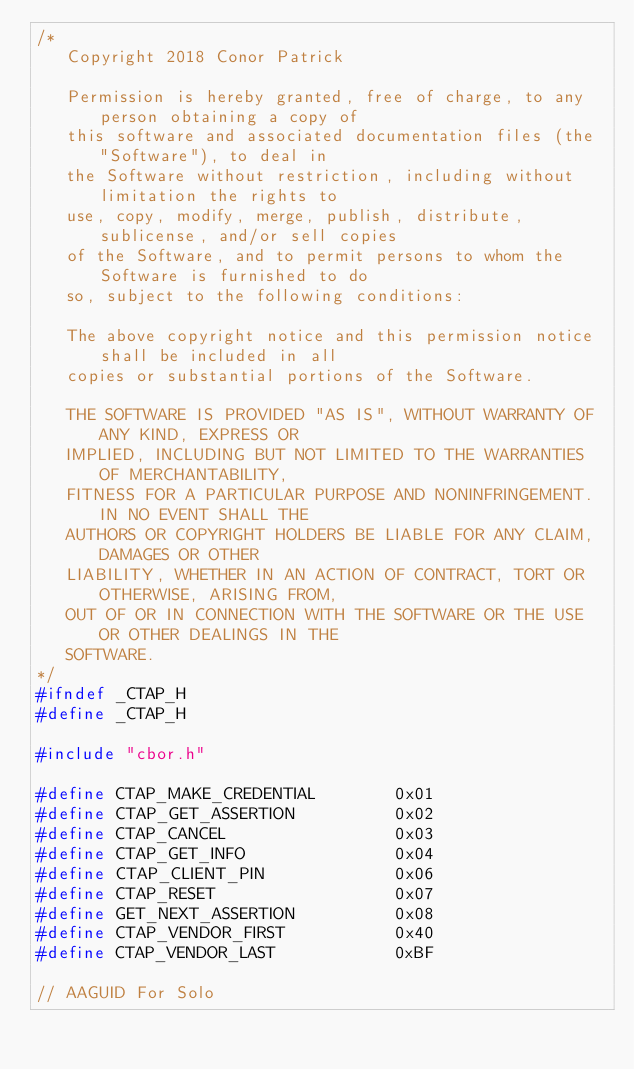Convert code to text. <code><loc_0><loc_0><loc_500><loc_500><_C_>/*
   Copyright 2018 Conor Patrick

   Permission is hereby granted, free of charge, to any person obtaining a copy of
   this software and associated documentation files (the "Software"), to deal in
   the Software without restriction, including without limitation the rights to
   use, copy, modify, merge, publish, distribute, sublicense, and/or sell copies
   of the Software, and to permit persons to whom the Software is furnished to do
   so, subject to the following conditions:

   The above copyright notice and this permission notice shall be included in all
   copies or substantial portions of the Software.

   THE SOFTWARE IS PROVIDED "AS IS", WITHOUT WARRANTY OF ANY KIND, EXPRESS OR
   IMPLIED, INCLUDING BUT NOT LIMITED TO THE WARRANTIES OF MERCHANTABILITY,
   FITNESS FOR A PARTICULAR PURPOSE AND NONINFRINGEMENT. IN NO EVENT SHALL THE
   AUTHORS OR COPYRIGHT HOLDERS BE LIABLE FOR ANY CLAIM, DAMAGES OR OTHER
   LIABILITY, WHETHER IN AN ACTION OF CONTRACT, TORT OR OTHERWISE, ARISING FROM,
   OUT OF OR IN CONNECTION WITH THE SOFTWARE OR THE USE OR OTHER DEALINGS IN THE
   SOFTWARE.
*/
#ifndef _CTAP_H
#define _CTAP_H

#include "cbor.h"

#define CTAP_MAKE_CREDENTIAL        0x01
#define CTAP_GET_ASSERTION          0x02
#define CTAP_CANCEL                 0x03
#define CTAP_GET_INFO               0x04
#define CTAP_CLIENT_PIN             0x06
#define CTAP_RESET                  0x07
#define GET_NEXT_ASSERTION          0x08
#define CTAP_VENDOR_FIRST           0x40
#define CTAP_VENDOR_LAST            0xBF

// AAGUID For Solo</code> 